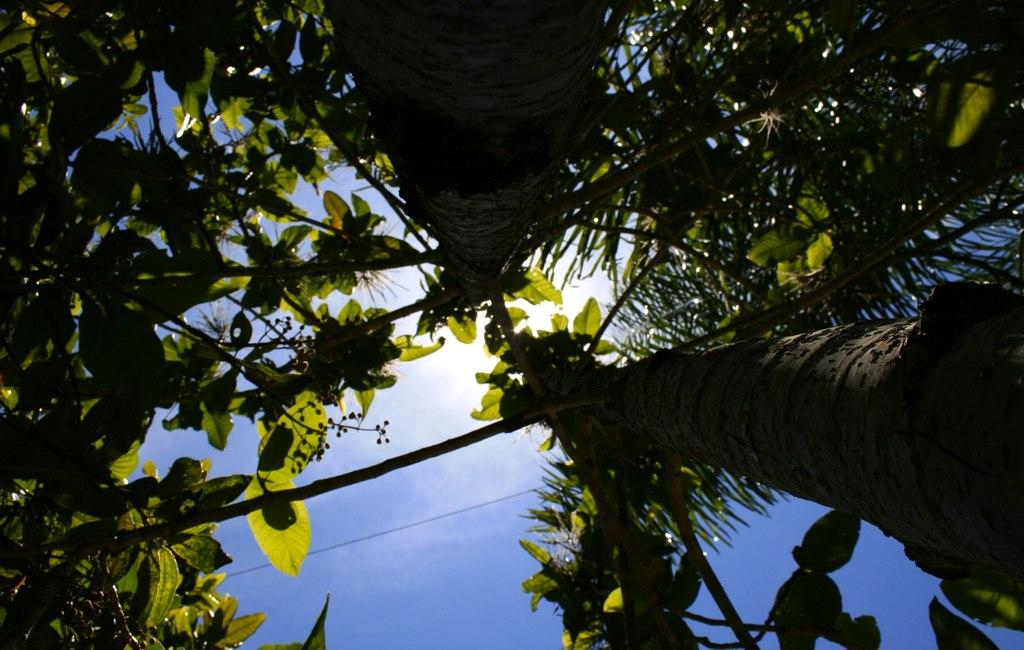What type of vegetation can be seen in the image? There are trees in the image. What celestial body is visible in the image? The sun is visible in the image. What part of the natural environment is visible in the image? The sky is visible in the image. What type of apparatus is being used for teaching in the image? There is no apparatus or teaching activity present in the image; it features trees, the sun, and the sky. 